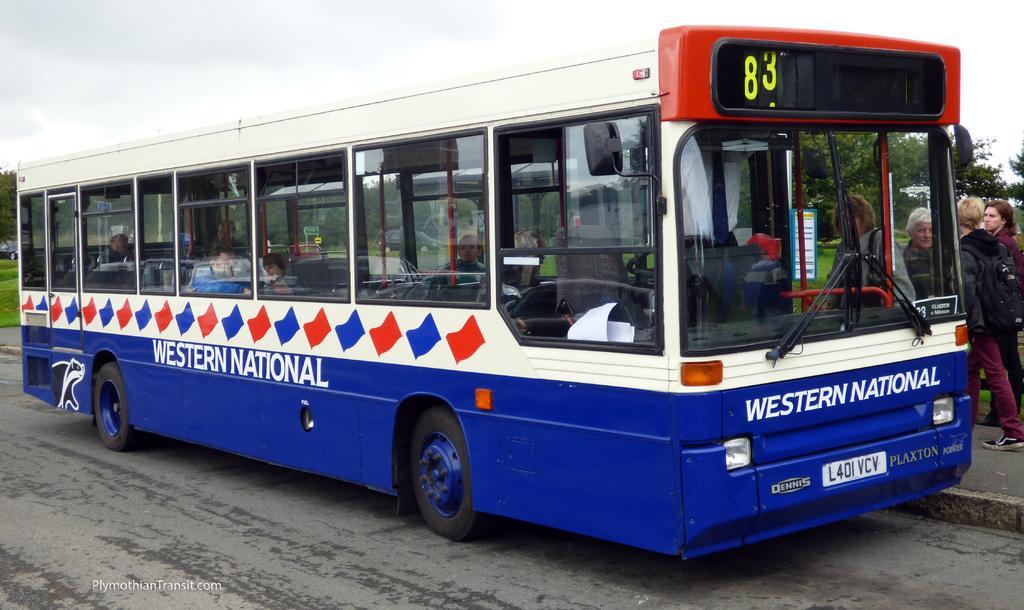Can you describe this image briefly? In this image we can see a bus which is in blue color on the road. Here we can see a few people walking on the sidewalk, we can see trees and the sky with clouds in the background. Here can see the watermark on the bottom left side of the image. 